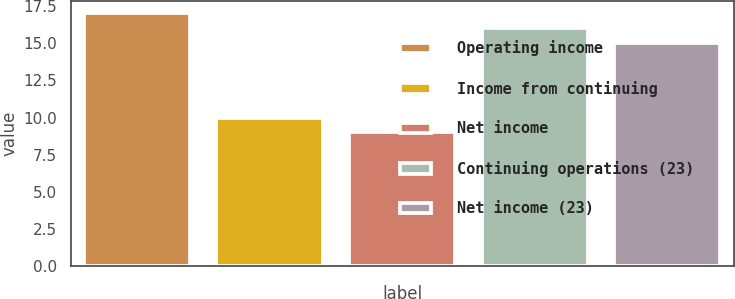Convert chart to OTSL. <chart><loc_0><loc_0><loc_500><loc_500><bar_chart><fcel>Operating income<fcel>Income from continuing<fcel>Net income<fcel>Continuing operations (23)<fcel>Net income (23)<nl><fcel>17<fcel>10<fcel>9<fcel>16<fcel>15<nl></chart> 